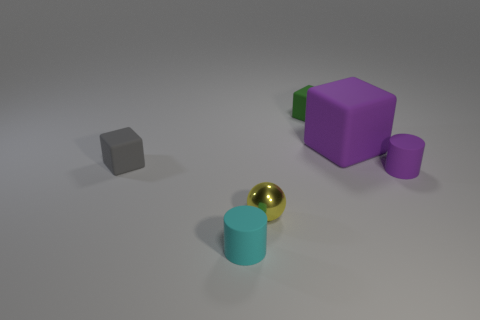There is a small matte cylinder that is behind the tiny cyan cylinder; is it the same color as the large matte block?
Give a very brief answer. Yes. Is the size of the rubber cylinder that is to the left of the purple rubber cylinder the same as the large purple object?
Provide a succinct answer. No. The large cube that is made of the same material as the cyan thing is what color?
Offer a very short reply. Purple. Is there any other thing that is the same size as the purple cube?
Make the answer very short. No. What number of tiny rubber cylinders are behind the small cyan matte thing?
Your answer should be very brief. 1. There is a big matte cube behind the purple cylinder; is it the same color as the small cylinder behind the ball?
Make the answer very short. Yes. What color is the other rubber thing that is the same shape as the cyan object?
Keep it short and to the point. Purple. Are there any other things that have the same shape as the metallic object?
Make the answer very short. No. Do the purple rubber object in front of the big matte thing and the tiny matte thing in front of the yellow object have the same shape?
Make the answer very short. Yes. There is a yellow thing; is it the same size as the cylinder to the right of the tiny cyan matte thing?
Give a very brief answer. Yes. 